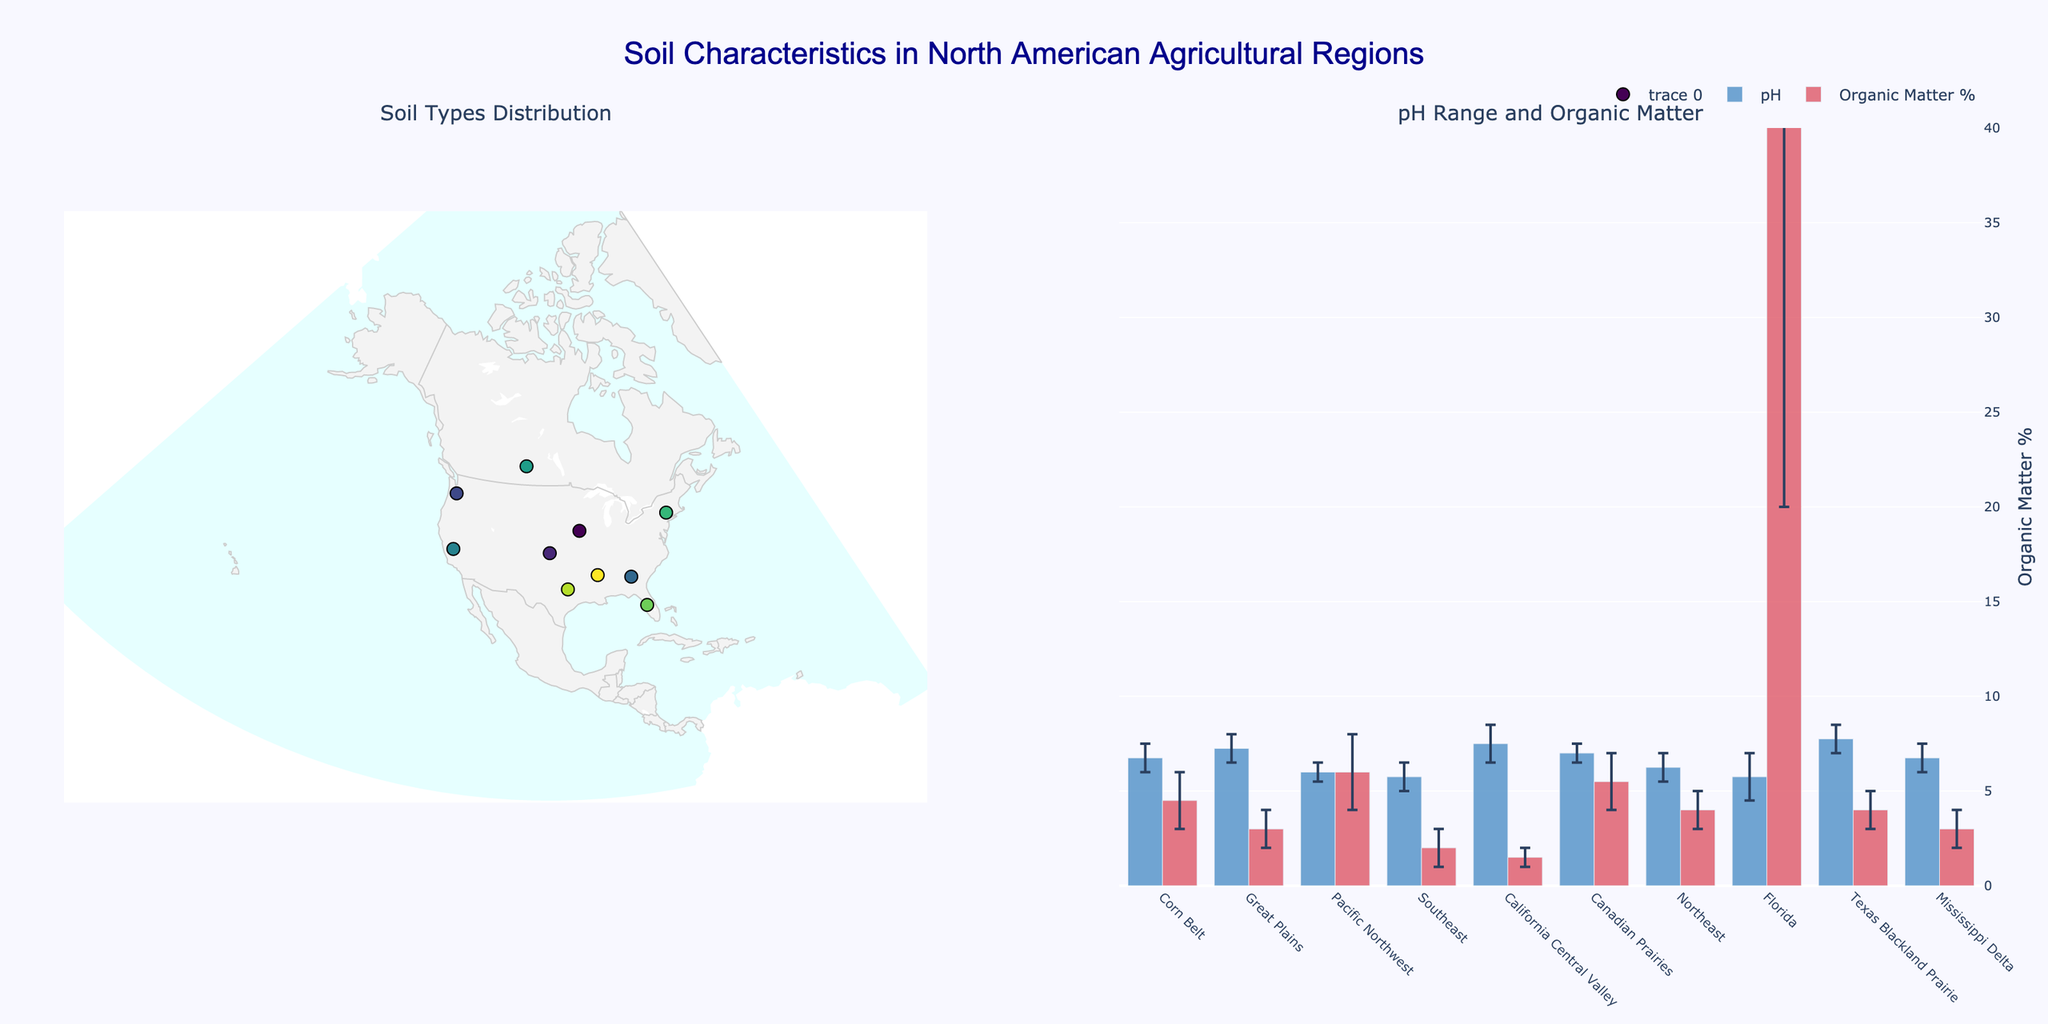What is the dominant soil type in the Corn Belt region? The map shows soil types with text labels for each region. The Corn Belt region is marked with "Mollisols."
Answer: Mollisols Which region has the widest pH range? In the pH bar plot, Florida's error bar spans from 4.5 to 7.0, indicating the widest range.
Answer: Florida What region has the highest organic matter percentage? The organic matter percentage is shown in the bar plot. Florida has the highest values, ranging from 20% to 80%.
Answer: Florida Which region has the lowest average organic matter percentage? The bar plot shows the average organic matter percentages (middle of the error bars). California Central Valley ranges from 1% to 2%, giving an average of 1.5%.
Answer: California Central Valley How does the pH range of Texas Blackland Prairie compare to the pH range of the Great Plains? The bar plot indicates Texas Blackland Prairie has a pH range of 7.0 to 8.5, while Great Plains has a range of 6.5 to 8.0. Both have overlapping ranges but Texas has a higher upper limit.
Answer: Texas has a higher upper limit Are there more regions with dominant soil types of Vertisols or Mollisols? Checking the dominant soil type labels on the map, there are three regions with Vertisols and two with Mollisols.
Answer: Vertisols What is the average pH range for the Northeast region? The bar plot shows the range for Northeast as 5.5 to 7.0. The average is (5.5 + 7.0) / 2 = 6.25.
Answer: 6.25 Which region has the smallest error bar for organic matter percentage? In the bar plot, the Southeast region has an error bar from 1% to 3%, which is the smallest range of 2%.
Answer: Southeast Which regions have Andisols as the dominant soil type? The map shows text labels for dominance. The Pacific Northwest is labeled with Andisols.
Answer: Pacific Northwest How does the organic matter percentage vary between the Canadian Prairies and the Mississippi Delta? The bar plot shows Canadian Prairies range from 4% to 7% and Mississippi Delta ranges from 2% to 4%.
Answer: Canadian Prairies have higher values 